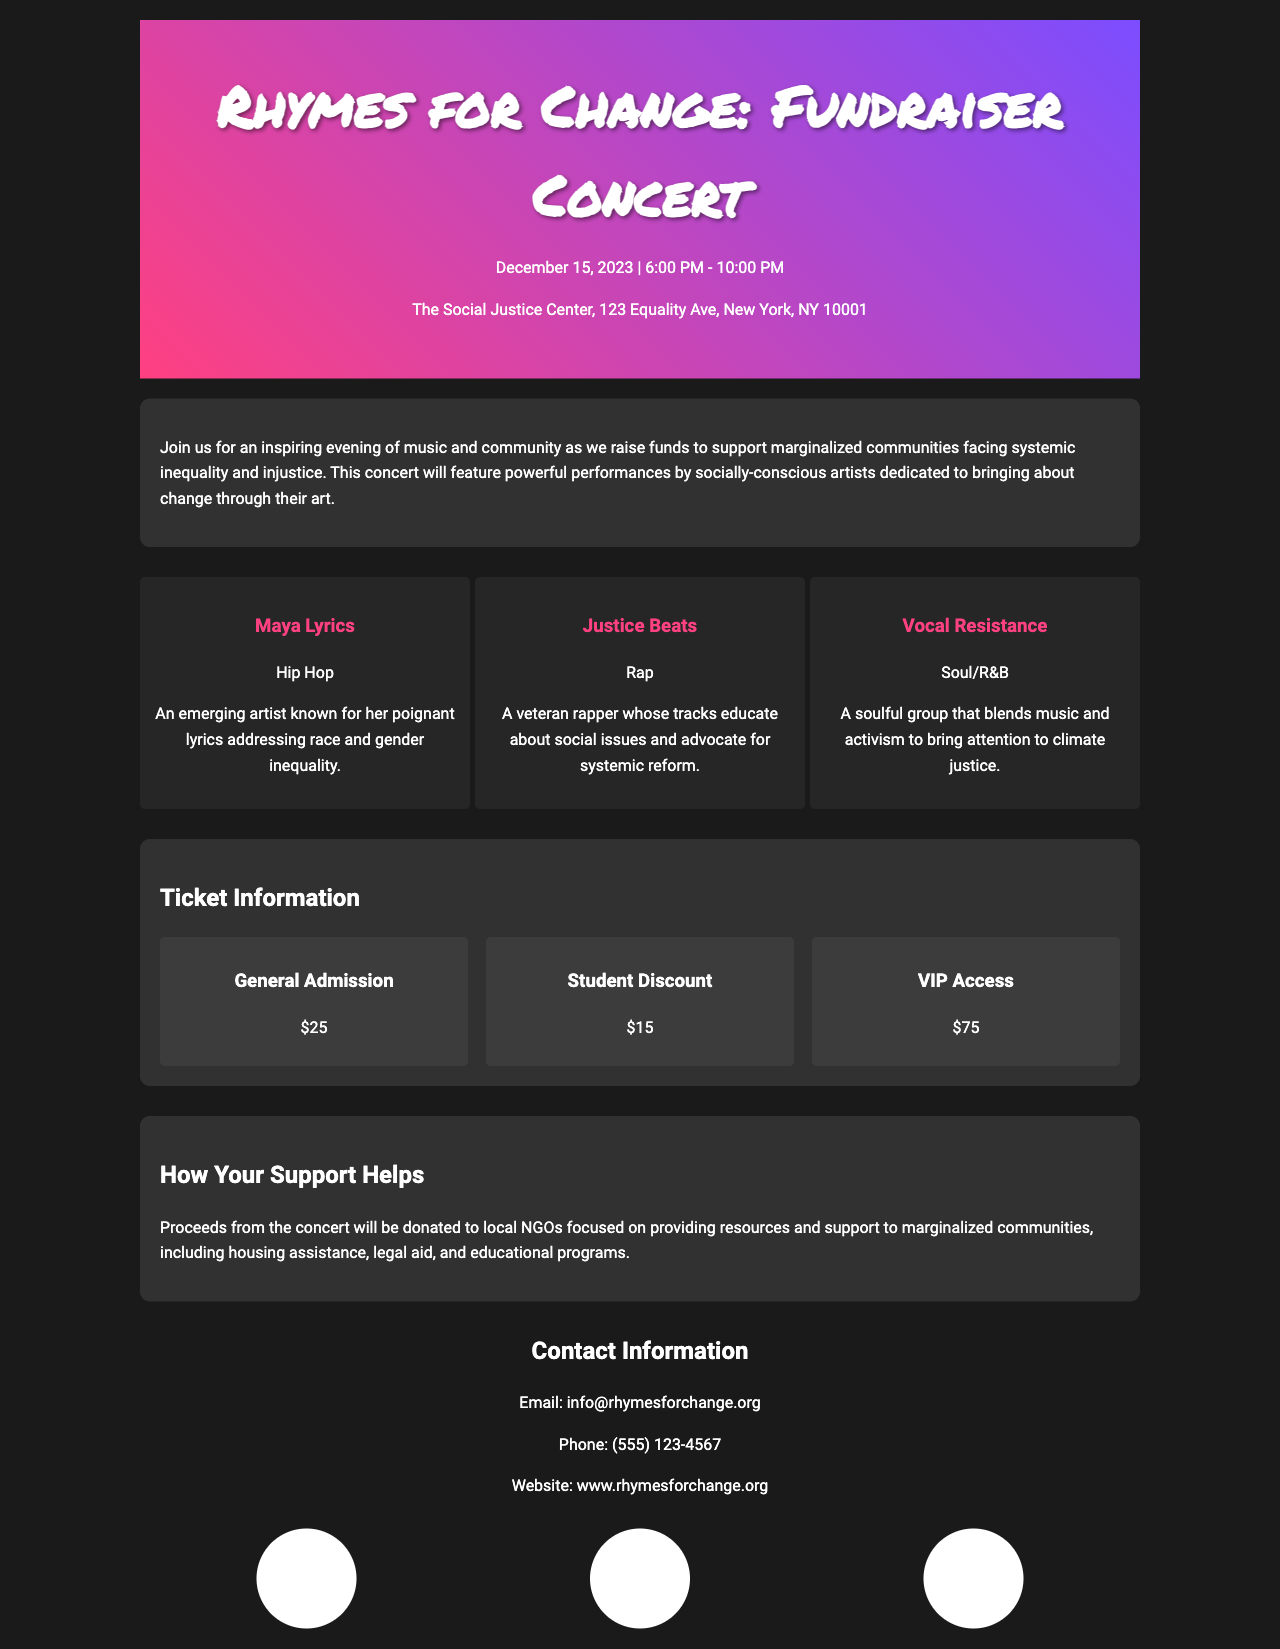What is the date of the concert? The concert is scheduled for December 15, 2023.
Answer: December 15, 2023 Who is one of the performers? The document lists performers including Maya Lyrics.
Answer: Maya Lyrics What is the venue for the concert? The venue information shows The Social Justice Center as the location.
Answer: The Social Justice Center How much is the student discount ticket? The document states that the student discount ticket costs $15.
Answer: $15 What kind of assistance will proceeds support? The document mentions that proceeds will help with housing assistance.
Answer: Housing assistance How long is the concert? The concert runs from 6:00 PM to 10:00 PM, indicating a duration of 4 hours.
Answer: 4 hours What is the VIP access ticket price? The ticket information lists VIP Access at $75.
Answer: $75 What type of event is this? The event is a fundraiser concert aimed at supporting marginalized communities.
Answer: Fundraiser concert What type of music will be performed? The document notes genres including Hip Hop and Rap.
Answer: Hip Hop and Rap 